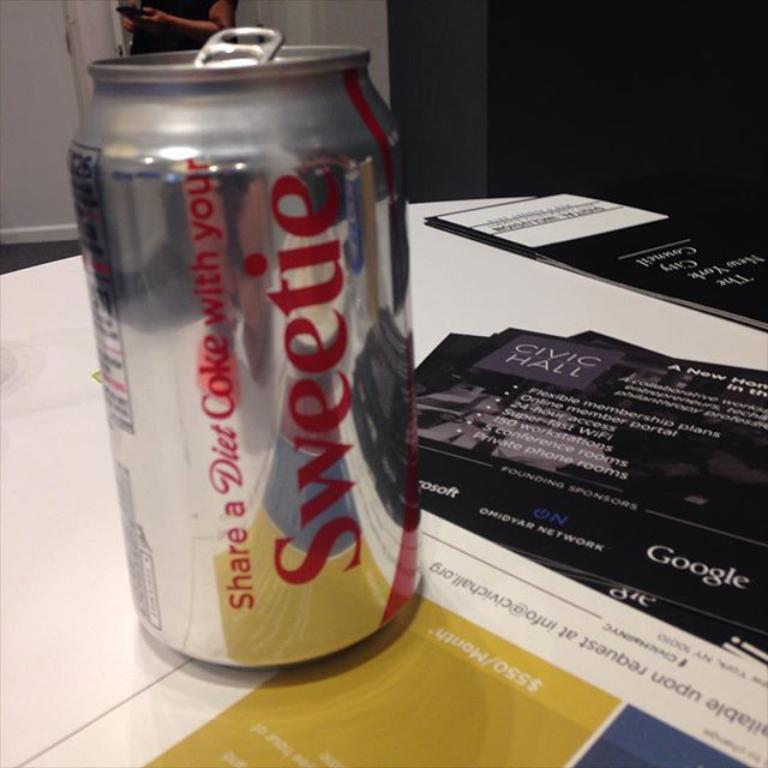<image>
Create a compact narrative representing the image presented. One of those diet coke cans with the name Sweetie on it. 